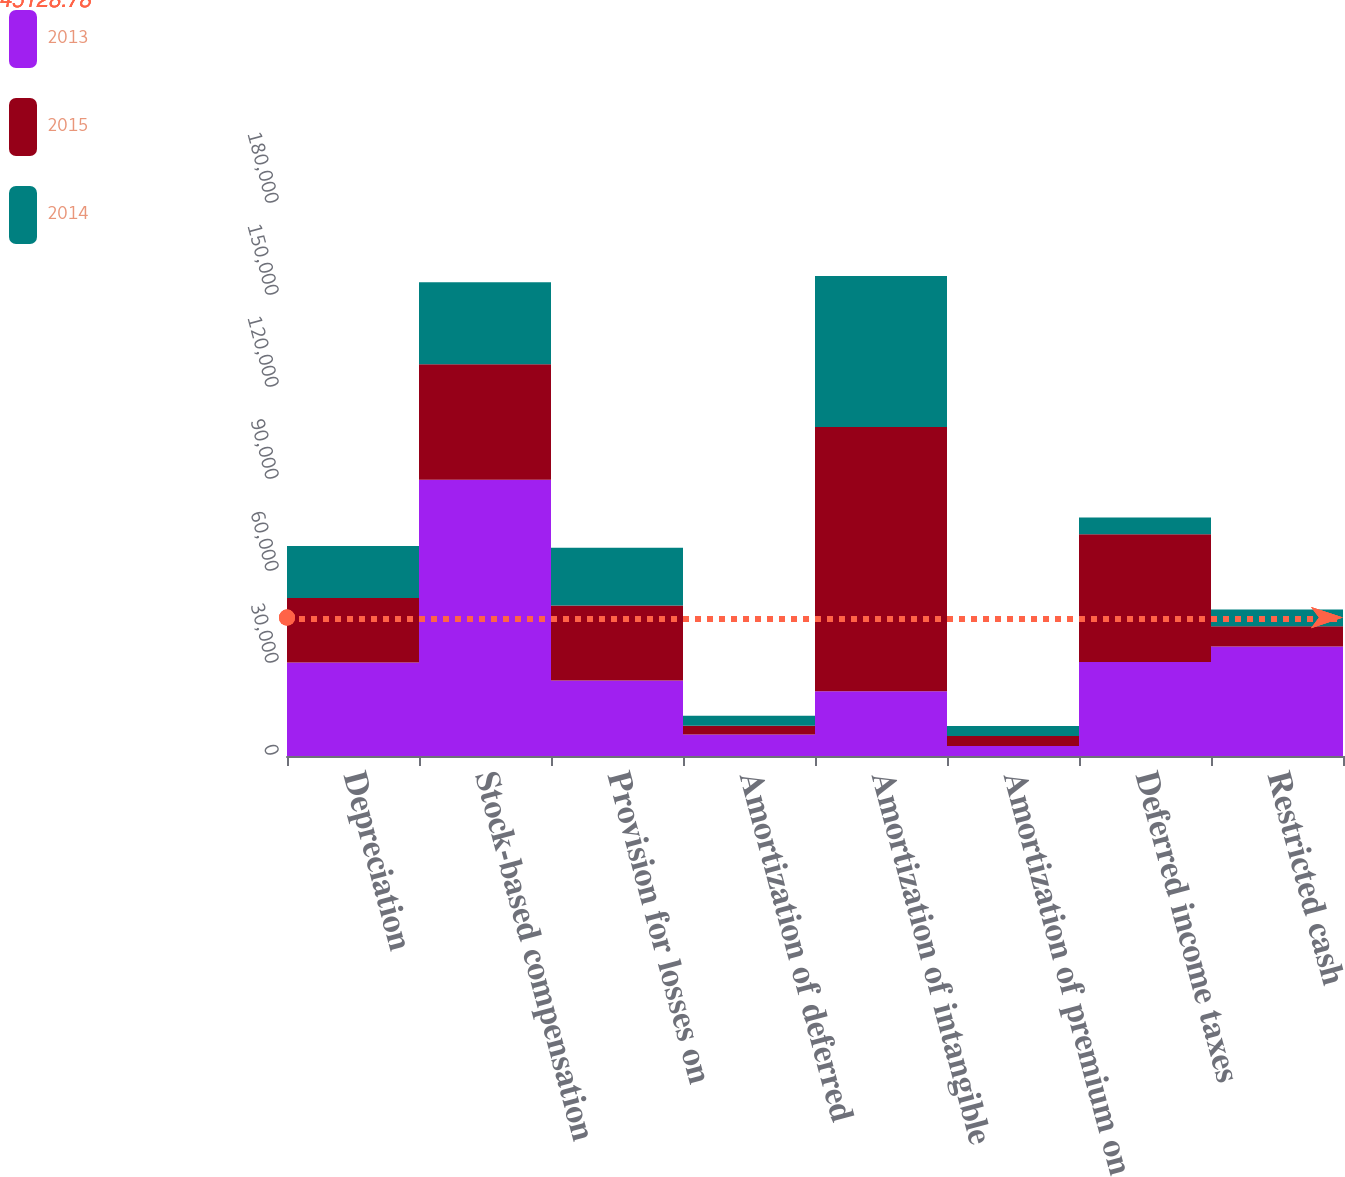Convert chart to OTSL. <chart><loc_0><loc_0><loc_500><loc_500><stacked_bar_chart><ecel><fcel>Depreciation<fcel>Stock-based compensation<fcel>Provision for losses on<fcel>Amortization of deferred<fcel>Amortization of intangible<fcel>Amortization of premium on<fcel>Deferred income taxes<fcel>Restricted cash<nl><fcel>2013<fcel>30462<fcel>90122<fcel>24629<fcel>7049<fcel>21097<fcel>3250<fcel>30626<fcel>35676<nl><fcel>2015<fcel>21097<fcel>37649<fcel>24412<fcel>2796<fcel>86149<fcel>3259<fcel>41716<fcel>6625<nl><fcel>2014<fcel>16885<fcel>26676<fcel>18867<fcel>3276<fcel>49313<fcel>3263<fcel>5453<fcel>5430<nl></chart> 